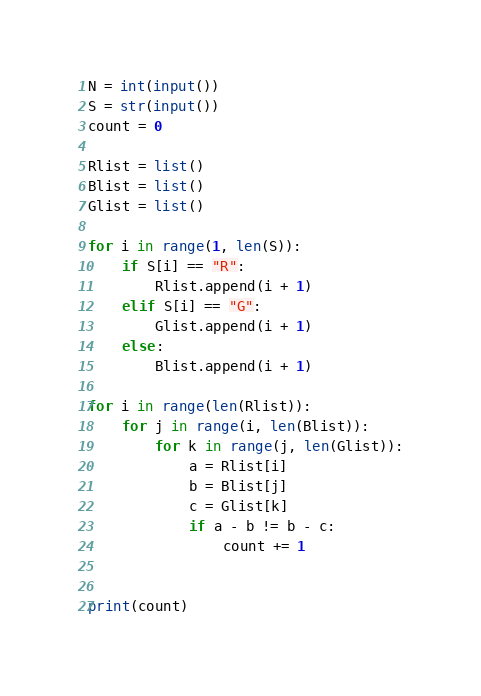<code> <loc_0><loc_0><loc_500><loc_500><_Python_>N = int(input())
S = str(input())
count = 0

Rlist = list()
Blist = list()
Glist = list()

for i in range(1, len(S)):
    if S[i] == "R":
        Rlist.append(i + 1)
    elif S[i] == "G":
        Glist.append(i + 1)
    else:
        Blist.append(i + 1)

for i in range(len(Rlist)):
    for j in range(i, len(Blist)):
        for k in range(j, len(Glist)):
            a = Rlist[i]
            b = Blist[j]
            c = Glist[k]
            if a - b != b - c:
                count += 1


print(count)
</code> 